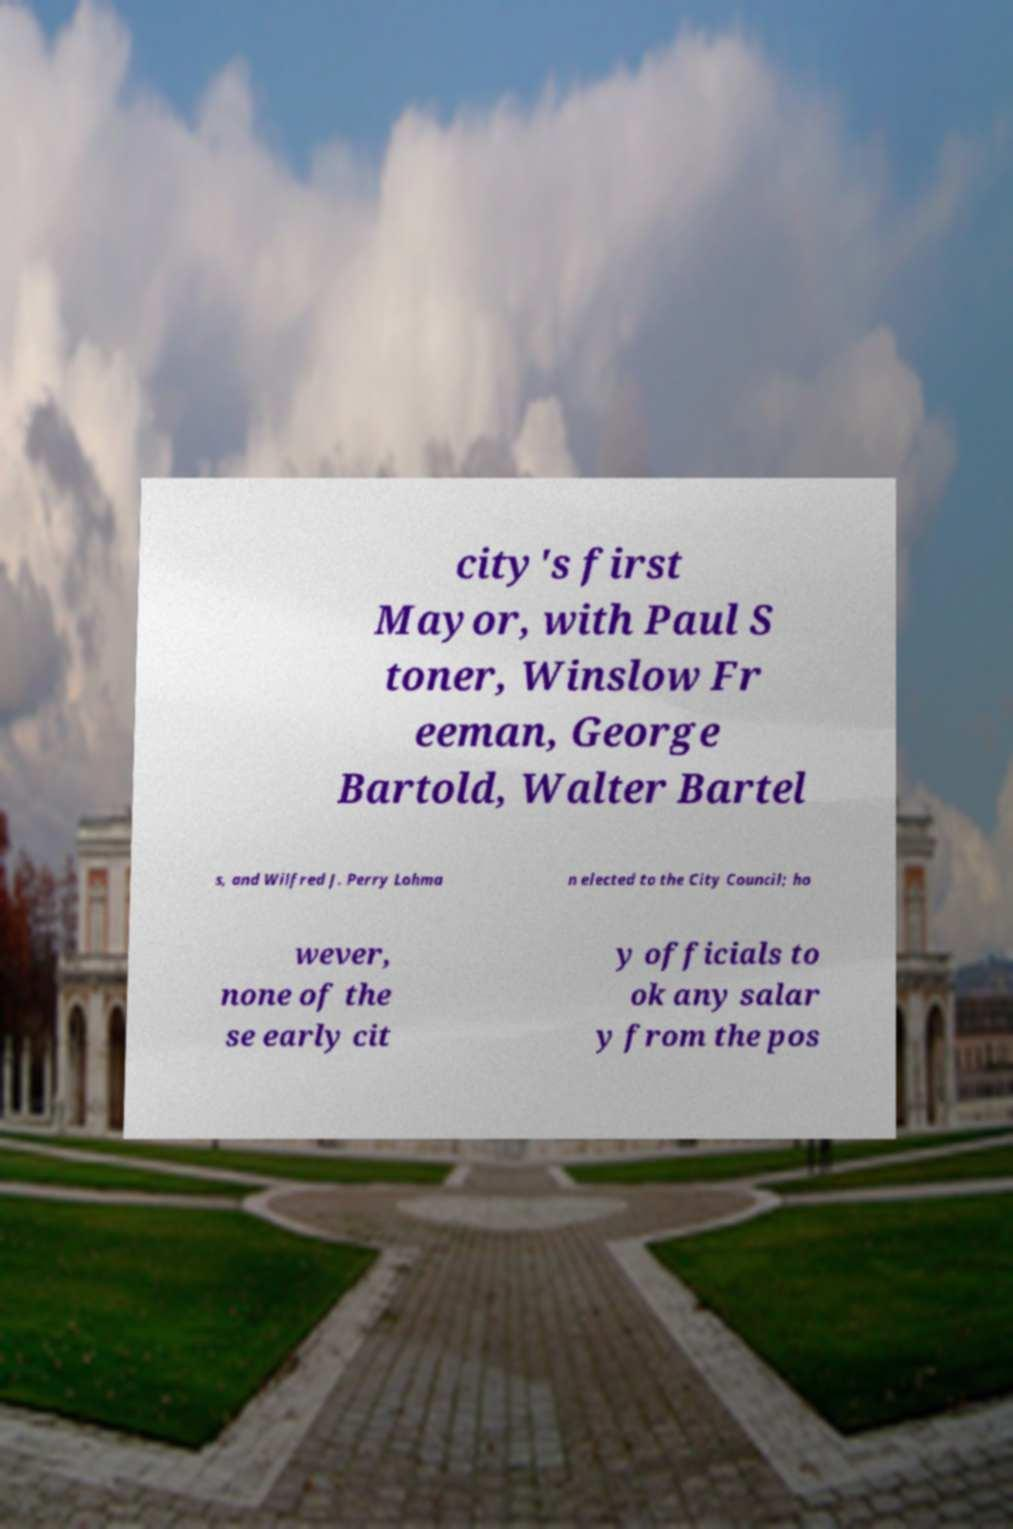Could you extract and type out the text from this image? city's first Mayor, with Paul S toner, Winslow Fr eeman, George Bartold, Walter Bartel s, and Wilfred J. Perry Lohma n elected to the City Council; ho wever, none of the se early cit y officials to ok any salar y from the pos 